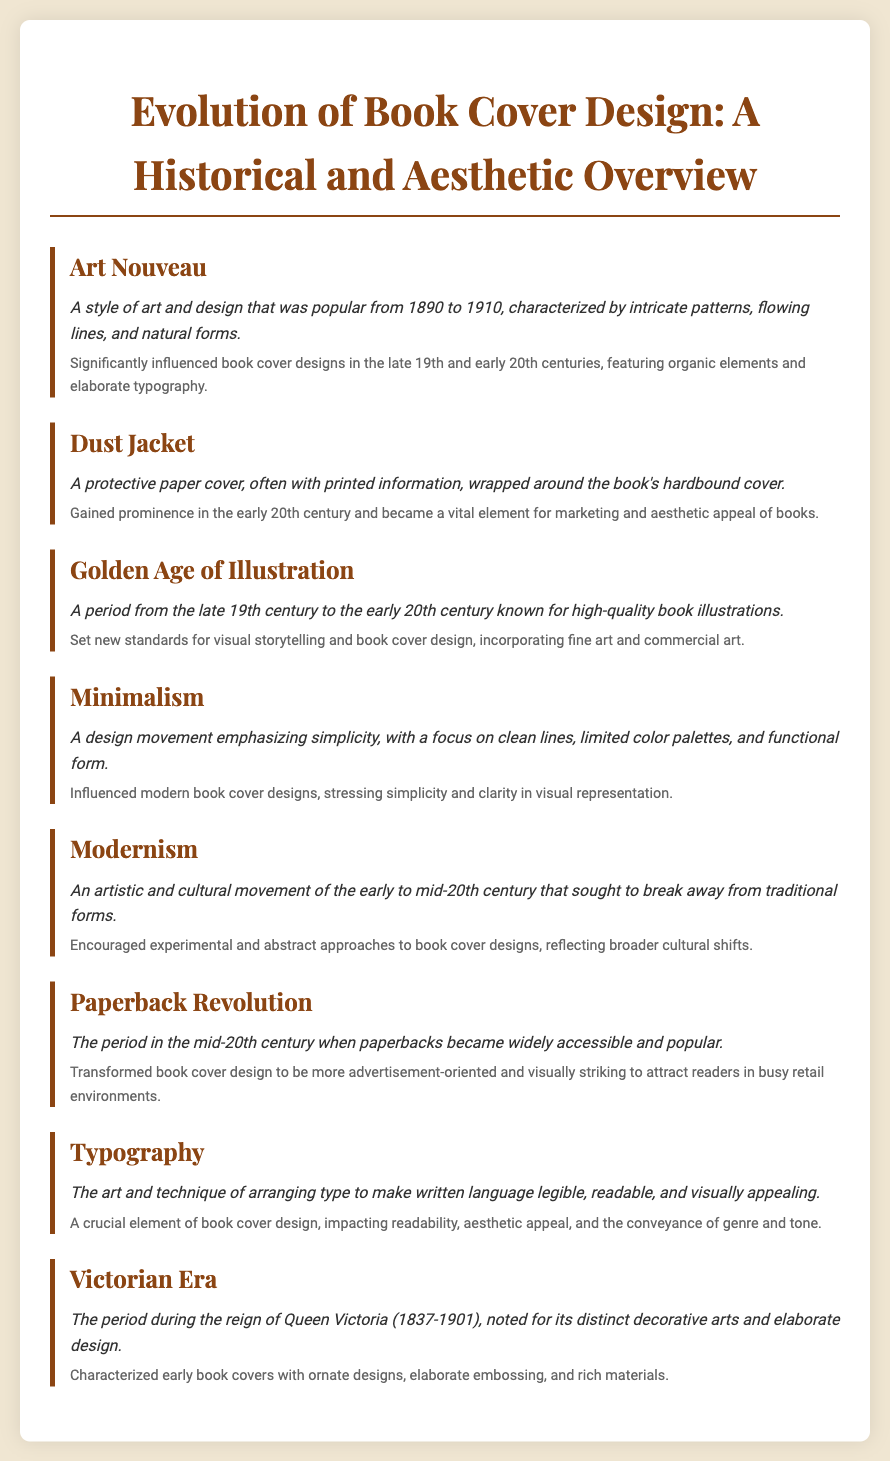What is the title of the document? The title of the document is displayed in the header and describes the content focus, which is the evolution of book cover design.
Answer: Evolution of Book Cover Design: A Historical and Aesthetic Overview What design movement is characterized by intricate patterns and flowing lines? This question refers to the specific style of design introduced in the glossary that has distinct characteristics and a time frame.
Answer: Art Nouveau What period is referred to as the Golden Age of Illustration? This period in the glossary denotes a timeframe known for significant developments in book illustrations.
Answer: Late 19th century to early 20th century Which cover type gained prominence in the early 20th century? This question looks for a specific feature of book design that became important for aesthetic and marketing purposes.
Answer: Dust Jacket What design style emphasizes simplicity and clean lines? The glossary provides a definition for a movement that focuses on minimalism in design.
Answer: Minimalism What was the main impact of the Paperback Revolution on book cover design? This question examines the transformation of cover design practices due to the popularity of a specific book format during a time period.
Answer: Advertisement-oriented and visually striking What is a critical element in book cover design that affects readability? The glossary includes a key concept that relates directly to making text visually appealing and understandable.
Answer: Typography During which era were book covers characterized by elaborate embossing? This question seeks to identify the historical period mentioned in the glossary that had specific aesthetic traits for book covers.
Answer: Victorian Era 